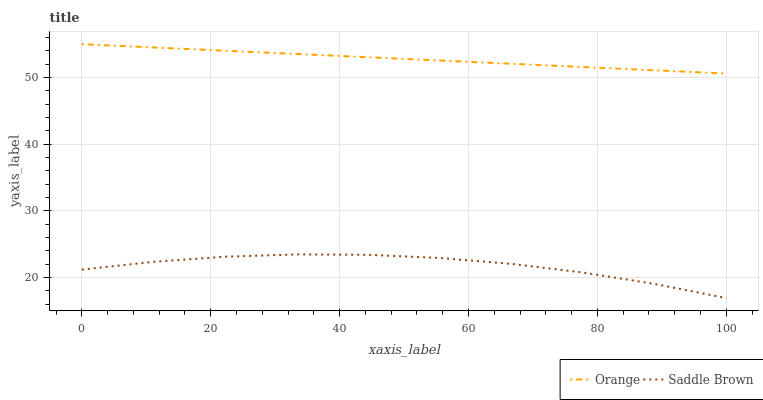Does Saddle Brown have the minimum area under the curve?
Answer yes or no. Yes. Does Orange have the maximum area under the curve?
Answer yes or no. Yes. Does Saddle Brown have the maximum area under the curve?
Answer yes or no. No. Is Orange the smoothest?
Answer yes or no. Yes. Is Saddle Brown the roughest?
Answer yes or no. Yes. Is Saddle Brown the smoothest?
Answer yes or no. No. Does Saddle Brown have the lowest value?
Answer yes or no. Yes. Does Orange have the highest value?
Answer yes or no. Yes. Does Saddle Brown have the highest value?
Answer yes or no. No. Is Saddle Brown less than Orange?
Answer yes or no. Yes. Is Orange greater than Saddle Brown?
Answer yes or no. Yes. Does Saddle Brown intersect Orange?
Answer yes or no. No. 